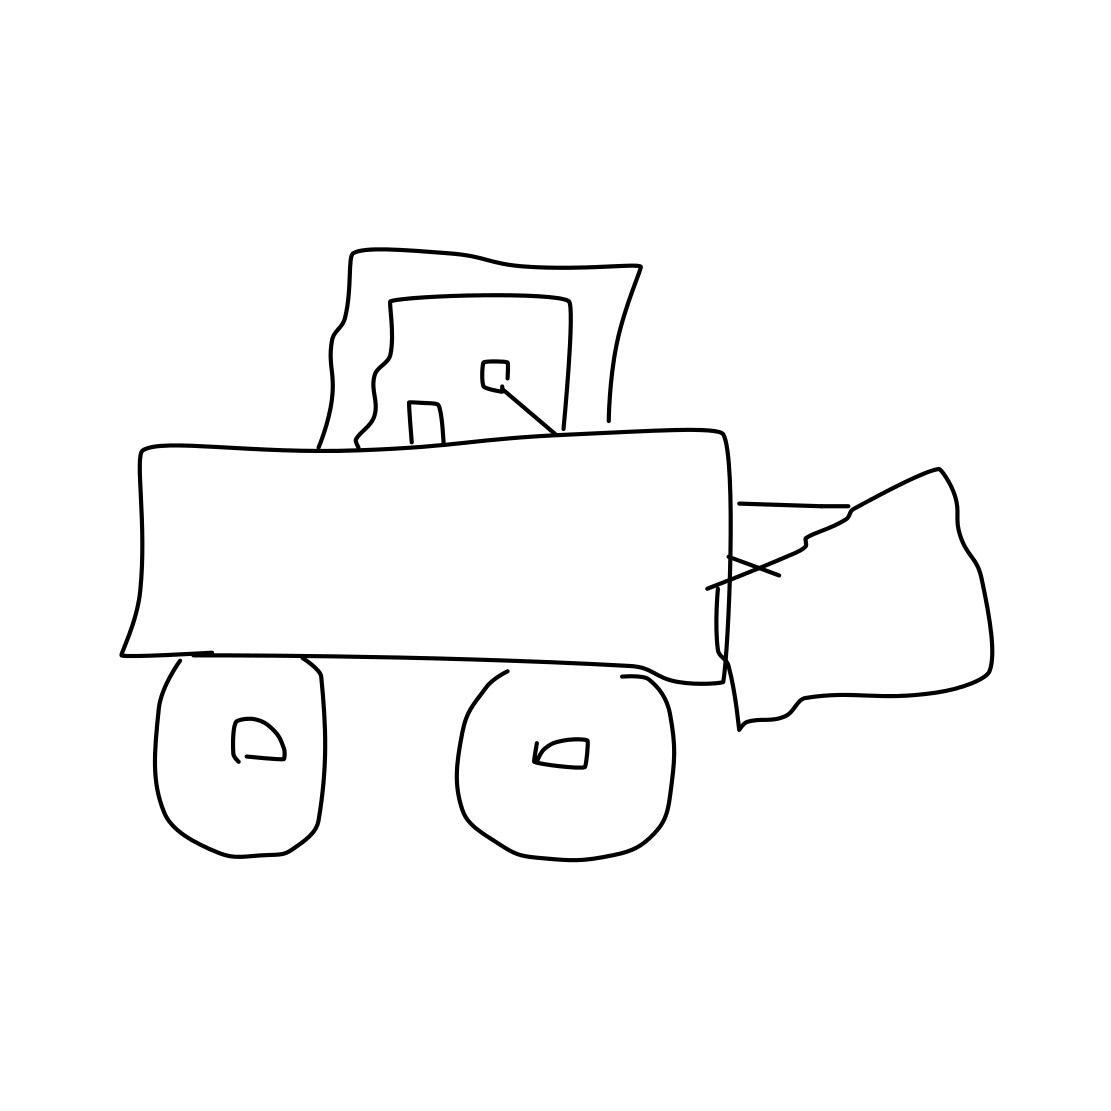Is this a nose in the image? From what we can observe in the image, it does not contain a depiction of a nose. Instead, the image appears to be a simple line drawing of a bulldozer, characterized by its large blade at the front, the cab where the operator sits, and wheels that typically enable movement and transport. 